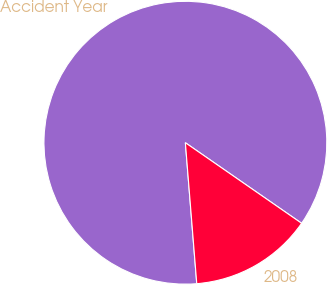Convert chart to OTSL. <chart><loc_0><loc_0><loc_500><loc_500><pie_chart><fcel>Accident Year<fcel>2008<nl><fcel>85.93%<fcel>14.07%<nl></chart> 